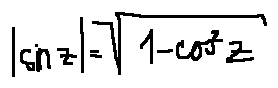<formula> <loc_0><loc_0><loc_500><loc_500>| \sin z | = \sqrt { 1 - \cos ^ { 2 } z }</formula> 